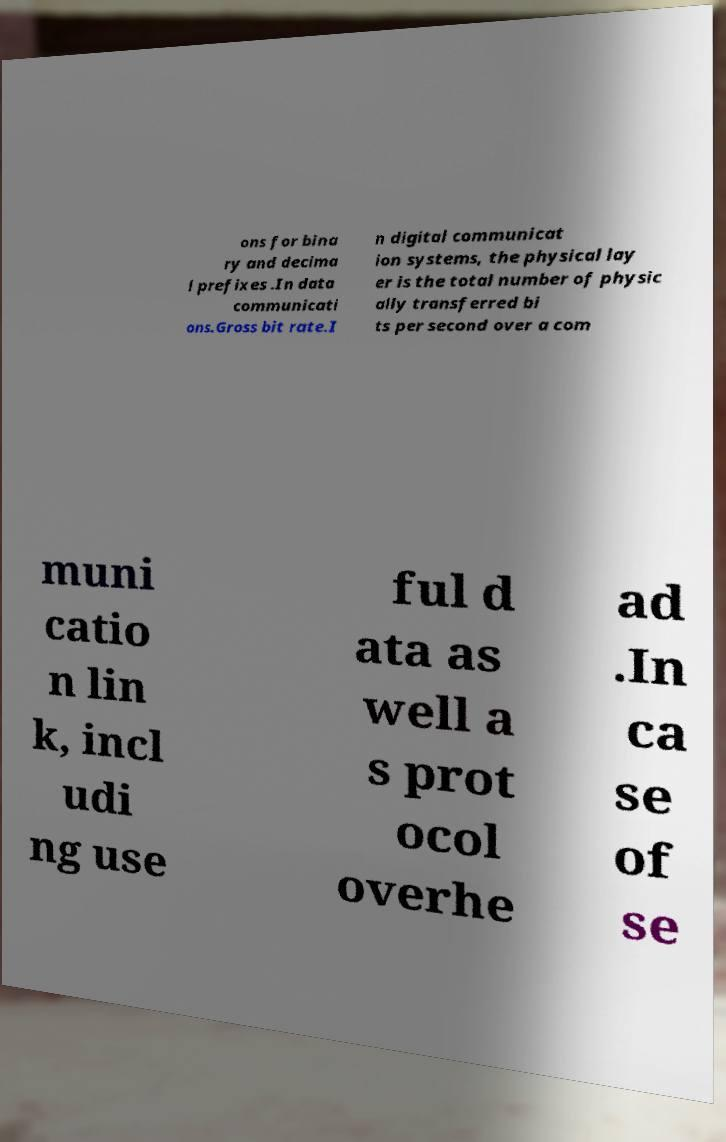For documentation purposes, I need the text within this image transcribed. Could you provide that? ons for bina ry and decima l prefixes .In data communicati ons.Gross bit rate.I n digital communicat ion systems, the physical lay er is the total number of physic ally transferred bi ts per second over a com muni catio n lin k, incl udi ng use ful d ata as well a s prot ocol overhe ad .In ca se of se 